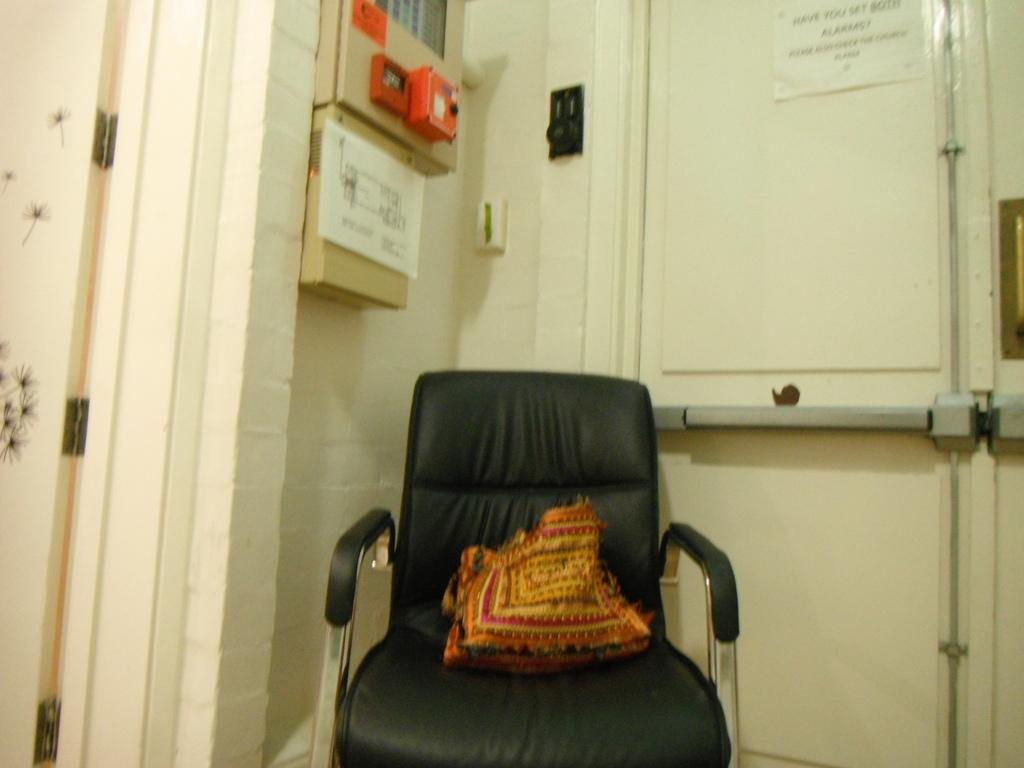What color is the chair in the image? The chair in the image is black. What is on the chair in the image? There is a multi-color object on the chair. What architectural feature can be seen in the image? There are doors visible in the image. What is attached to the wall in the image? There are boards attached to the cream wall in the image. How many children are playing on the floor in the image? There are no children visible in the image. Did the earthquake cause any damage to the chair in the image? There is no mention of an earthquake in the provided facts, and no damage is visible on the chair. 